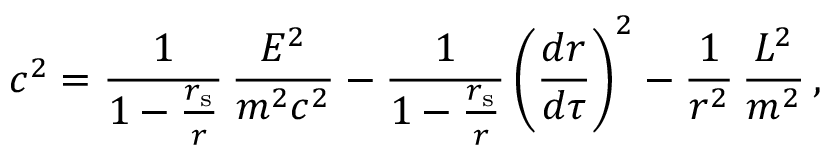Convert formula to latex. <formula><loc_0><loc_0><loc_500><loc_500>c ^ { 2 } = { \frac { 1 } { 1 - { \frac { r _ { s } } { r } } } } \, { \frac { E ^ { 2 } } { m ^ { 2 } c ^ { 2 } } } - { \frac { 1 } { 1 - { \frac { r _ { s } } { r } } } } \left ( { \frac { d r } { d \tau } } \right ) ^ { 2 } - { \frac { 1 } { r ^ { 2 } } } \, { \frac { L ^ { 2 } } { m ^ { 2 } } } \, ,</formula> 